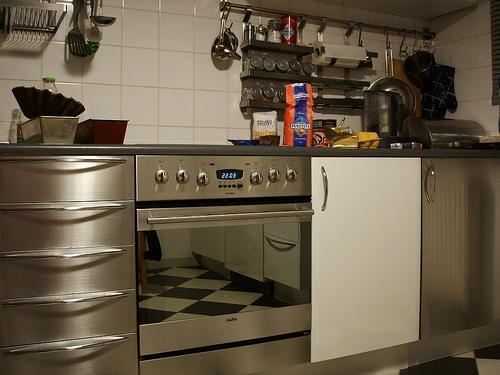How many knobs are shown?
Give a very brief answer. 6. 